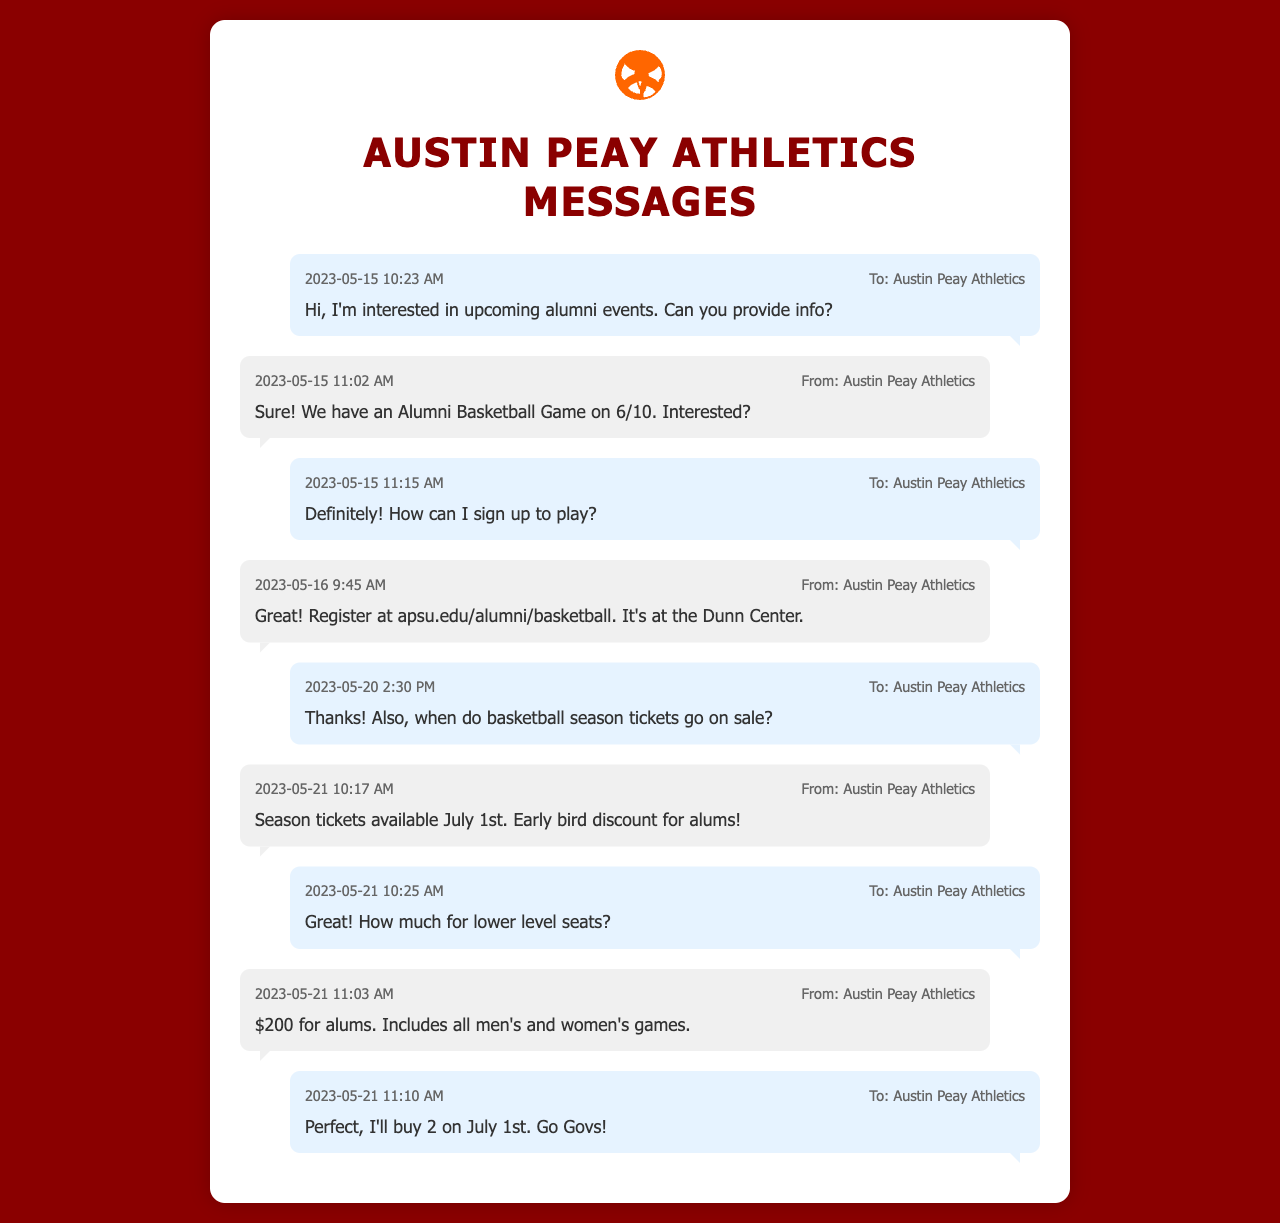what is the date of the Alumni Basketball Game? The date for the Alumni Basketball Game is mentioned in the response from Austin Peay Athletics.
Answer: 6/10 who did you text to inquire about alumni events? The recipient of the texts is Austin Peay Athletics, as stated in the outgoing messages.
Answer: Austin Peay Athletics how much do lower level season tickets cost for alums? The cost for lower level seats is specified in a reply from Austin Peay Athletics.
Answer: $200 what time was the message sent asking about basketball season tickets? The time is indicated in the outgoing message on May 20, where the sender inquires about the season tickets.
Answer: 2:30 PM when will season tickets be available? The message from Austin Peay Athletics specifies when the season tickets will be available.
Answer: July 1st how many tickets did the sender plan to buy? The sender indicates the number of tickets they intend to purchase in the last outgoing message.
Answer: 2 what is the website for registration for the Alumni Basketball Game? The website for registration is provided in the response from Austin Peay Athletics.
Answer: apsu.edu/alumni/basketball what was the last message's sentiment from the sender? The last message reflects excitement and support for the team, as expressed by the sender.
Answer: Go Govs! 